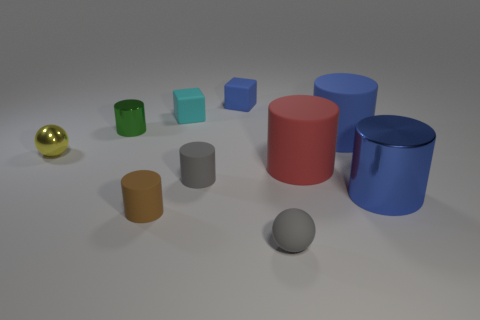Subtract all red cylinders. How many cylinders are left? 5 Subtract all blocks. How many objects are left? 8 Subtract all purple cylinders. Subtract all yellow spheres. How many objects are left? 9 Add 2 small gray matte objects. How many small gray matte objects are left? 4 Add 5 small blue metal balls. How many small blue metal balls exist? 5 Subtract all cyan blocks. How many blocks are left? 1 Subtract 0 red balls. How many objects are left? 10 Subtract 1 cubes. How many cubes are left? 1 Subtract all green blocks. Subtract all brown balls. How many blocks are left? 2 Subtract all cyan balls. How many brown cylinders are left? 1 